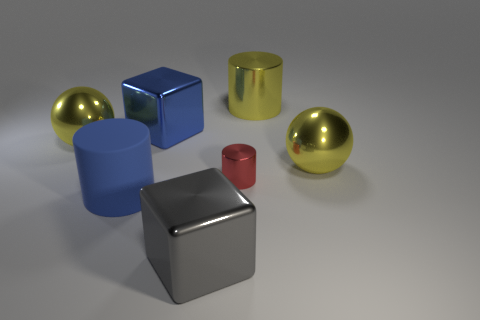How do the lighting conditions in the image affect the appearance of the objects? The lighting conditions create subtle shadows and enhance the texture of the objects. Reflective surfaces, like the shiny cube and spheres, reflect the light strongly, giving them a bright sheen, while the matte surfaces absorb light, resulting in a softer appearance. Is there a light source visible within the image? There is no direct light source visible in the image; however, the reflections and shadows suggest an overhead or off-camera light source illuminating the scene. 